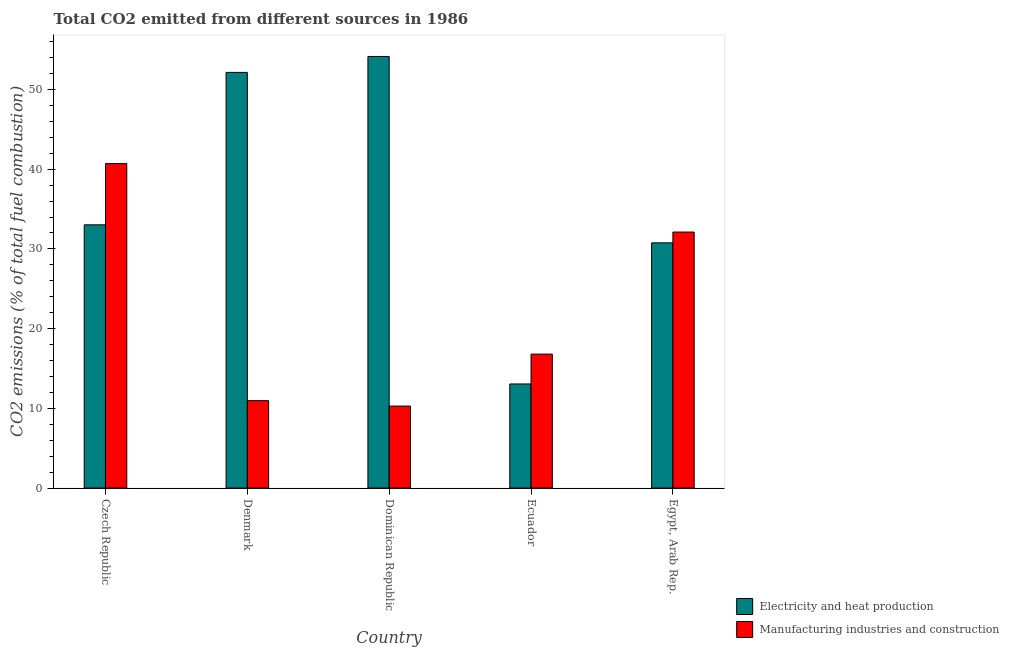How many different coloured bars are there?
Offer a very short reply. 2. How many groups of bars are there?
Your answer should be very brief. 5. Are the number of bars on each tick of the X-axis equal?
Your answer should be compact. Yes. How many bars are there on the 5th tick from the left?
Provide a succinct answer. 2. How many bars are there on the 1st tick from the right?
Offer a terse response. 2. What is the label of the 5th group of bars from the left?
Keep it short and to the point. Egypt, Arab Rep. What is the co2 emissions due to electricity and heat production in Dominican Republic?
Your answer should be very brief. 54.14. Across all countries, what is the maximum co2 emissions due to electricity and heat production?
Your answer should be very brief. 54.14. Across all countries, what is the minimum co2 emissions due to electricity and heat production?
Your answer should be compact. 13.06. In which country was the co2 emissions due to manufacturing industries maximum?
Offer a very short reply. Czech Republic. In which country was the co2 emissions due to manufacturing industries minimum?
Provide a succinct answer. Dominican Republic. What is the total co2 emissions due to manufacturing industries in the graph?
Your response must be concise. 110.88. What is the difference between the co2 emissions due to manufacturing industries in Denmark and that in Egypt, Arab Rep.?
Give a very brief answer. -21.15. What is the difference between the co2 emissions due to electricity and heat production in Denmark and the co2 emissions due to manufacturing industries in Egypt, Arab Rep.?
Offer a terse response. 20.03. What is the average co2 emissions due to manufacturing industries per country?
Give a very brief answer. 22.18. What is the difference between the co2 emissions due to manufacturing industries and co2 emissions due to electricity and heat production in Dominican Republic?
Make the answer very short. -43.86. What is the ratio of the co2 emissions due to manufacturing industries in Dominican Republic to that in Ecuador?
Your response must be concise. 0.61. Is the co2 emissions due to electricity and heat production in Czech Republic less than that in Denmark?
Offer a very short reply. Yes. Is the difference between the co2 emissions due to electricity and heat production in Dominican Republic and Egypt, Arab Rep. greater than the difference between the co2 emissions due to manufacturing industries in Dominican Republic and Egypt, Arab Rep.?
Provide a succinct answer. Yes. What is the difference between the highest and the second highest co2 emissions due to electricity and heat production?
Make the answer very short. 2. What is the difference between the highest and the lowest co2 emissions due to manufacturing industries?
Keep it short and to the point. 30.42. Is the sum of the co2 emissions due to electricity and heat production in Denmark and Dominican Republic greater than the maximum co2 emissions due to manufacturing industries across all countries?
Your response must be concise. Yes. What does the 1st bar from the left in Ecuador represents?
Your answer should be compact. Electricity and heat production. What does the 1st bar from the right in Czech Republic represents?
Offer a terse response. Manufacturing industries and construction. Are all the bars in the graph horizontal?
Your answer should be very brief. No. How many legend labels are there?
Give a very brief answer. 2. How are the legend labels stacked?
Your response must be concise. Vertical. What is the title of the graph?
Offer a very short reply. Total CO2 emitted from different sources in 1986. What is the label or title of the X-axis?
Provide a short and direct response. Country. What is the label or title of the Y-axis?
Provide a short and direct response. CO2 emissions (% of total fuel combustion). What is the CO2 emissions (% of total fuel combustion) of Electricity and heat production in Czech Republic?
Make the answer very short. 33.02. What is the CO2 emissions (% of total fuel combustion) in Manufacturing industries and construction in Czech Republic?
Provide a succinct answer. 40.71. What is the CO2 emissions (% of total fuel combustion) in Electricity and heat production in Denmark?
Give a very brief answer. 52.14. What is the CO2 emissions (% of total fuel combustion) of Manufacturing industries and construction in Denmark?
Your answer should be compact. 10.97. What is the CO2 emissions (% of total fuel combustion) in Electricity and heat production in Dominican Republic?
Offer a terse response. 54.14. What is the CO2 emissions (% of total fuel combustion) in Manufacturing industries and construction in Dominican Republic?
Ensure brevity in your answer.  10.29. What is the CO2 emissions (% of total fuel combustion) in Electricity and heat production in Ecuador?
Make the answer very short. 13.06. What is the CO2 emissions (% of total fuel combustion) of Manufacturing industries and construction in Ecuador?
Offer a very short reply. 16.81. What is the CO2 emissions (% of total fuel combustion) in Electricity and heat production in Egypt, Arab Rep.?
Ensure brevity in your answer.  30.76. What is the CO2 emissions (% of total fuel combustion) of Manufacturing industries and construction in Egypt, Arab Rep.?
Keep it short and to the point. 32.12. Across all countries, what is the maximum CO2 emissions (% of total fuel combustion) in Electricity and heat production?
Your answer should be compact. 54.14. Across all countries, what is the maximum CO2 emissions (% of total fuel combustion) of Manufacturing industries and construction?
Give a very brief answer. 40.71. Across all countries, what is the minimum CO2 emissions (% of total fuel combustion) in Electricity and heat production?
Your response must be concise. 13.06. Across all countries, what is the minimum CO2 emissions (% of total fuel combustion) in Manufacturing industries and construction?
Keep it short and to the point. 10.29. What is the total CO2 emissions (% of total fuel combustion) of Electricity and heat production in the graph?
Provide a succinct answer. 183.13. What is the total CO2 emissions (% of total fuel combustion) of Manufacturing industries and construction in the graph?
Provide a short and direct response. 110.88. What is the difference between the CO2 emissions (% of total fuel combustion) of Electricity and heat production in Czech Republic and that in Denmark?
Provide a short and direct response. -19.12. What is the difference between the CO2 emissions (% of total fuel combustion) of Manufacturing industries and construction in Czech Republic and that in Denmark?
Make the answer very short. 29.74. What is the difference between the CO2 emissions (% of total fuel combustion) of Electricity and heat production in Czech Republic and that in Dominican Republic?
Your response must be concise. -21.12. What is the difference between the CO2 emissions (% of total fuel combustion) in Manufacturing industries and construction in Czech Republic and that in Dominican Republic?
Your answer should be very brief. 30.42. What is the difference between the CO2 emissions (% of total fuel combustion) in Electricity and heat production in Czech Republic and that in Ecuador?
Offer a terse response. 19.96. What is the difference between the CO2 emissions (% of total fuel combustion) of Manufacturing industries and construction in Czech Republic and that in Ecuador?
Your answer should be very brief. 23.9. What is the difference between the CO2 emissions (% of total fuel combustion) of Electricity and heat production in Czech Republic and that in Egypt, Arab Rep.?
Keep it short and to the point. 2.26. What is the difference between the CO2 emissions (% of total fuel combustion) in Manufacturing industries and construction in Czech Republic and that in Egypt, Arab Rep.?
Make the answer very short. 8.59. What is the difference between the CO2 emissions (% of total fuel combustion) of Electricity and heat production in Denmark and that in Dominican Republic?
Keep it short and to the point. -2. What is the difference between the CO2 emissions (% of total fuel combustion) of Manufacturing industries and construction in Denmark and that in Dominican Republic?
Your answer should be very brief. 0.68. What is the difference between the CO2 emissions (% of total fuel combustion) in Electricity and heat production in Denmark and that in Ecuador?
Make the answer very short. 39.08. What is the difference between the CO2 emissions (% of total fuel combustion) in Manufacturing industries and construction in Denmark and that in Ecuador?
Your response must be concise. -5.84. What is the difference between the CO2 emissions (% of total fuel combustion) of Electricity and heat production in Denmark and that in Egypt, Arab Rep.?
Provide a succinct answer. 21.38. What is the difference between the CO2 emissions (% of total fuel combustion) in Manufacturing industries and construction in Denmark and that in Egypt, Arab Rep.?
Your answer should be very brief. -21.15. What is the difference between the CO2 emissions (% of total fuel combustion) of Electricity and heat production in Dominican Republic and that in Ecuador?
Provide a short and direct response. 41.08. What is the difference between the CO2 emissions (% of total fuel combustion) of Manufacturing industries and construction in Dominican Republic and that in Ecuador?
Provide a succinct answer. -6.52. What is the difference between the CO2 emissions (% of total fuel combustion) in Electricity and heat production in Dominican Republic and that in Egypt, Arab Rep.?
Give a very brief answer. 23.38. What is the difference between the CO2 emissions (% of total fuel combustion) of Manufacturing industries and construction in Dominican Republic and that in Egypt, Arab Rep.?
Provide a succinct answer. -21.83. What is the difference between the CO2 emissions (% of total fuel combustion) of Electricity and heat production in Ecuador and that in Egypt, Arab Rep.?
Offer a terse response. -17.7. What is the difference between the CO2 emissions (% of total fuel combustion) in Manufacturing industries and construction in Ecuador and that in Egypt, Arab Rep.?
Ensure brevity in your answer.  -15.31. What is the difference between the CO2 emissions (% of total fuel combustion) of Electricity and heat production in Czech Republic and the CO2 emissions (% of total fuel combustion) of Manufacturing industries and construction in Denmark?
Your response must be concise. 22.06. What is the difference between the CO2 emissions (% of total fuel combustion) in Electricity and heat production in Czech Republic and the CO2 emissions (% of total fuel combustion) in Manufacturing industries and construction in Dominican Republic?
Keep it short and to the point. 22.74. What is the difference between the CO2 emissions (% of total fuel combustion) in Electricity and heat production in Czech Republic and the CO2 emissions (% of total fuel combustion) in Manufacturing industries and construction in Ecuador?
Keep it short and to the point. 16.22. What is the difference between the CO2 emissions (% of total fuel combustion) of Electricity and heat production in Czech Republic and the CO2 emissions (% of total fuel combustion) of Manufacturing industries and construction in Egypt, Arab Rep.?
Your response must be concise. 0.91. What is the difference between the CO2 emissions (% of total fuel combustion) in Electricity and heat production in Denmark and the CO2 emissions (% of total fuel combustion) in Manufacturing industries and construction in Dominican Republic?
Your answer should be compact. 41.86. What is the difference between the CO2 emissions (% of total fuel combustion) in Electricity and heat production in Denmark and the CO2 emissions (% of total fuel combustion) in Manufacturing industries and construction in Ecuador?
Ensure brevity in your answer.  35.34. What is the difference between the CO2 emissions (% of total fuel combustion) in Electricity and heat production in Denmark and the CO2 emissions (% of total fuel combustion) in Manufacturing industries and construction in Egypt, Arab Rep.?
Offer a terse response. 20.03. What is the difference between the CO2 emissions (% of total fuel combustion) in Electricity and heat production in Dominican Republic and the CO2 emissions (% of total fuel combustion) in Manufacturing industries and construction in Ecuador?
Provide a short and direct response. 37.34. What is the difference between the CO2 emissions (% of total fuel combustion) of Electricity and heat production in Dominican Republic and the CO2 emissions (% of total fuel combustion) of Manufacturing industries and construction in Egypt, Arab Rep.?
Provide a short and direct response. 22.03. What is the difference between the CO2 emissions (% of total fuel combustion) in Electricity and heat production in Ecuador and the CO2 emissions (% of total fuel combustion) in Manufacturing industries and construction in Egypt, Arab Rep.?
Provide a short and direct response. -19.06. What is the average CO2 emissions (% of total fuel combustion) in Electricity and heat production per country?
Offer a very short reply. 36.63. What is the average CO2 emissions (% of total fuel combustion) in Manufacturing industries and construction per country?
Give a very brief answer. 22.18. What is the difference between the CO2 emissions (% of total fuel combustion) in Electricity and heat production and CO2 emissions (% of total fuel combustion) in Manufacturing industries and construction in Czech Republic?
Your answer should be very brief. -7.68. What is the difference between the CO2 emissions (% of total fuel combustion) in Electricity and heat production and CO2 emissions (% of total fuel combustion) in Manufacturing industries and construction in Denmark?
Provide a short and direct response. 41.18. What is the difference between the CO2 emissions (% of total fuel combustion) of Electricity and heat production and CO2 emissions (% of total fuel combustion) of Manufacturing industries and construction in Dominican Republic?
Make the answer very short. 43.86. What is the difference between the CO2 emissions (% of total fuel combustion) of Electricity and heat production and CO2 emissions (% of total fuel combustion) of Manufacturing industries and construction in Ecuador?
Offer a very short reply. -3.74. What is the difference between the CO2 emissions (% of total fuel combustion) in Electricity and heat production and CO2 emissions (% of total fuel combustion) in Manufacturing industries and construction in Egypt, Arab Rep.?
Give a very brief answer. -1.35. What is the ratio of the CO2 emissions (% of total fuel combustion) of Electricity and heat production in Czech Republic to that in Denmark?
Give a very brief answer. 0.63. What is the ratio of the CO2 emissions (% of total fuel combustion) in Manufacturing industries and construction in Czech Republic to that in Denmark?
Offer a terse response. 3.71. What is the ratio of the CO2 emissions (% of total fuel combustion) in Electricity and heat production in Czech Republic to that in Dominican Republic?
Give a very brief answer. 0.61. What is the ratio of the CO2 emissions (% of total fuel combustion) in Manufacturing industries and construction in Czech Republic to that in Dominican Republic?
Your answer should be compact. 3.96. What is the ratio of the CO2 emissions (% of total fuel combustion) in Electricity and heat production in Czech Republic to that in Ecuador?
Offer a very short reply. 2.53. What is the ratio of the CO2 emissions (% of total fuel combustion) in Manufacturing industries and construction in Czech Republic to that in Ecuador?
Ensure brevity in your answer.  2.42. What is the ratio of the CO2 emissions (% of total fuel combustion) in Electricity and heat production in Czech Republic to that in Egypt, Arab Rep.?
Keep it short and to the point. 1.07. What is the ratio of the CO2 emissions (% of total fuel combustion) of Manufacturing industries and construction in Czech Republic to that in Egypt, Arab Rep.?
Offer a very short reply. 1.27. What is the ratio of the CO2 emissions (% of total fuel combustion) in Electricity and heat production in Denmark to that in Dominican Republic?
Your answer should be very brief. 0.96. What is the ratio of the CO2 emissions (% of total fuel combustion) of Manufacturing industries and construction in Denmark to that in Dominican Republic?
Make the answer very short. 1.07. What is the ratio of the CO2 emissions (% of total fuel combustion) of Electricity and heat production in Denmark to that in Ecuador?
Your answer should be very brief. 3.99. What is the ratio of the CO2 emissions (% of total fuel combustion) of Manufacturing industries and construction in Denmark to that in Ecuador?
Give a very brief answer. 0.65. What is the ratio of the CO2 emissions (% of total fuel combustion) of Electricity and heat production in Denmark to that in Egypt, Arab Rep.?
Offer a very short reply. 1.7. What is the ratio of the CO2 emissions (% of total fuel combustion) in Manufacturing industries and construction in Denmark to that in Egypt, Arab Rep.?
Provide a short and direct response. 0.34. What is the ratio of the CO2 emissions (% of total fuel combustion) in Electricity and heat production in Dominican Republic to that in Ecuador?
Your answer should be compact. 4.15. What is the ratio of the CO2 emissions (% of total fuel combustion) in Manufacturing industries and construction in Dominican Republic to that in Ecuador?
Your answer should be compact. 0.61. What is the ratio of the CO2 emissions (% of total fuel combustion) in Electricity and heat production in Dominican Republic to that in Egypt, Arab Rep.?
Give a very brief answer. 1.76. What is the ratio of the CO2 emissions (% of total fuel combustion) of Manufacturing industries and construction in Dominican Republic to that in Egypt, Arab Rep.?
Offer a very short reply. 0.32. What is the ratio of the CO2 emissions (% of total fuel combustion) in Electricity and heat production in Ecuador to that in Egypt, Arab Rep.?
Make the answer very short. 0.42. What is the ratio of the CO2 emissions (% of total fuel combustion) of Manufacturing industries and construction in Ecuador to that in Egypt, Arab Rep.?
Keep it short and to the point. 0.52. What is the difference between the highest and the second highest CO2 emissions (% of total fuel combustion) of Electricity and heat production?
Offer a very short reply. 2. What is the difference between the highest and the second highest CO2 emissions (% of total fuel combustion) in Manufacturing industries and construction?
Your answer should be very brief. 8.59. What is the difference between the highest and the lowest CO2 emissions (% of total fuel combustion) in Electricity and heat production?
Ensure brevity in your answer.  41.08. What is the difference between the highest and the lowest CO2 emissions (% of total fuel combustion) in Manufacturing industries and construction?
Your answer should be compact. 30.42. 